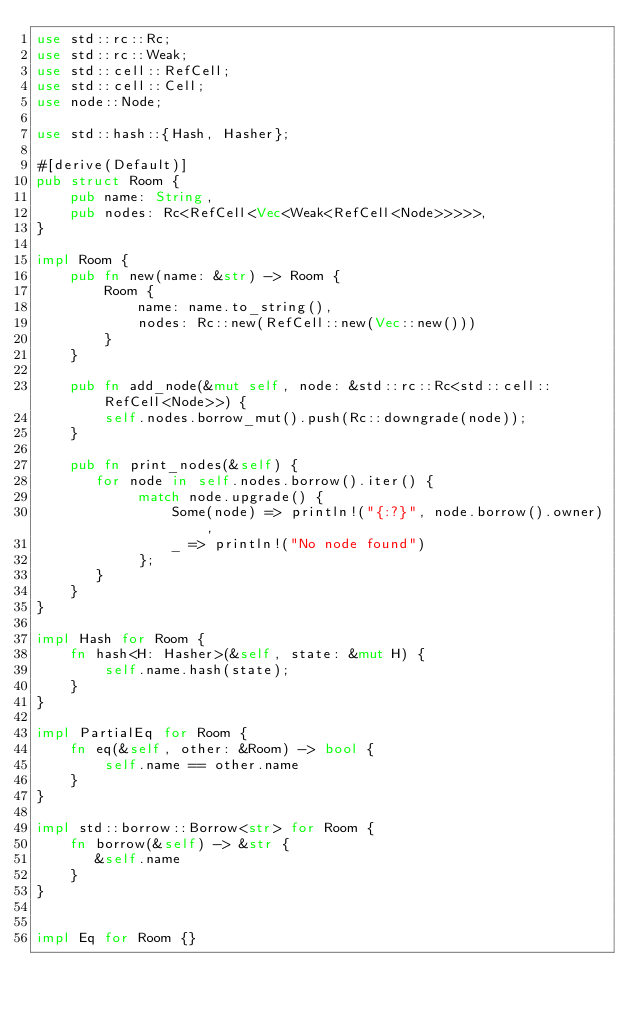Convert code to text. <code><loc_0><loc_0><loc_500><loc_500><_Rust_>use std::rc::Rc;
use std::rc::Weak;
use std::cell::RefCell;
use std::cell::Cell;
use node::Node;

use std::hash::{Hash, Hasher};

#[derive(Default)]
pub struct Room {
    pub name: String,
    pub nodes: Rc<RefCell<Vec<Weak<RefCell<Node>>>>>,
}

impl Room {
    pub fn new(name: &str) -> Room {
        Room {
            name: name.to_string(),
            nodes: Rc::new(RefCell::new(Vec::new()))
        }
    } 

    pub fn add_node(&mut self, node: &std::rc::Rc<std::cell::RefCell<Node>>) {
        self.nodes.borrow_mut().push(Rc::downgrade(node));
    }

    pub fn print_nodes(&self) {
       for node in self.nodes.borrow().iter() {
            match node.upgrade() {
                Some(node) => println!("{:?}", node.borrow().owner),
                _ => println!("No node found")
            };
       }
    }
}

impl Hash for Room {
    fn hash<H: Hasher>(&self, state: &mut H) {
        self.name.hash(state);
    }
}

impl PartialEq for Room {
    fn eq(&self, other: &Room) -> bool {
        self.name == other.name
    }
}

impl std::borrow::Borrow<str> for Room {
    fn borrow(&self) -> &str {
       &self.name
    }
}


impl Eq for Room {}</code> 